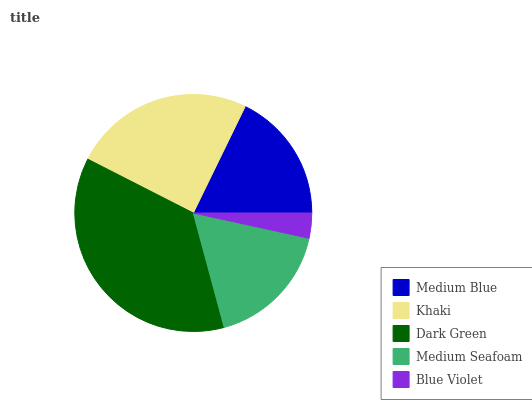Is Blue Violet the minimum?
Answer yes or no. Yes. Is Dark Green the maximum?
Answer yes or no. Yes. Is Khaki the minimum?
Answer yes or no. No. Is Khaki the maximum?
Answer yes or no. No. Is Khaki greater than Medium Blue?
Answer yes or no. Yes. Is Medium Blue less than Khaki?
Answer yes or no. Yes. Is Medium Blue greater than Khaki?
Answer yes or no. No. Is Khaki less than Medium Blue?
Answer yes or no. No. Is Medium Blue the high median?
Answer yes or no. Yes. Is Medium Blue the low median?
Answer yes or no. Yes. Is Dark Green the high median?
Answer yes or no. No. Is Blue Violet the low median?
Answer yes or no. No. 